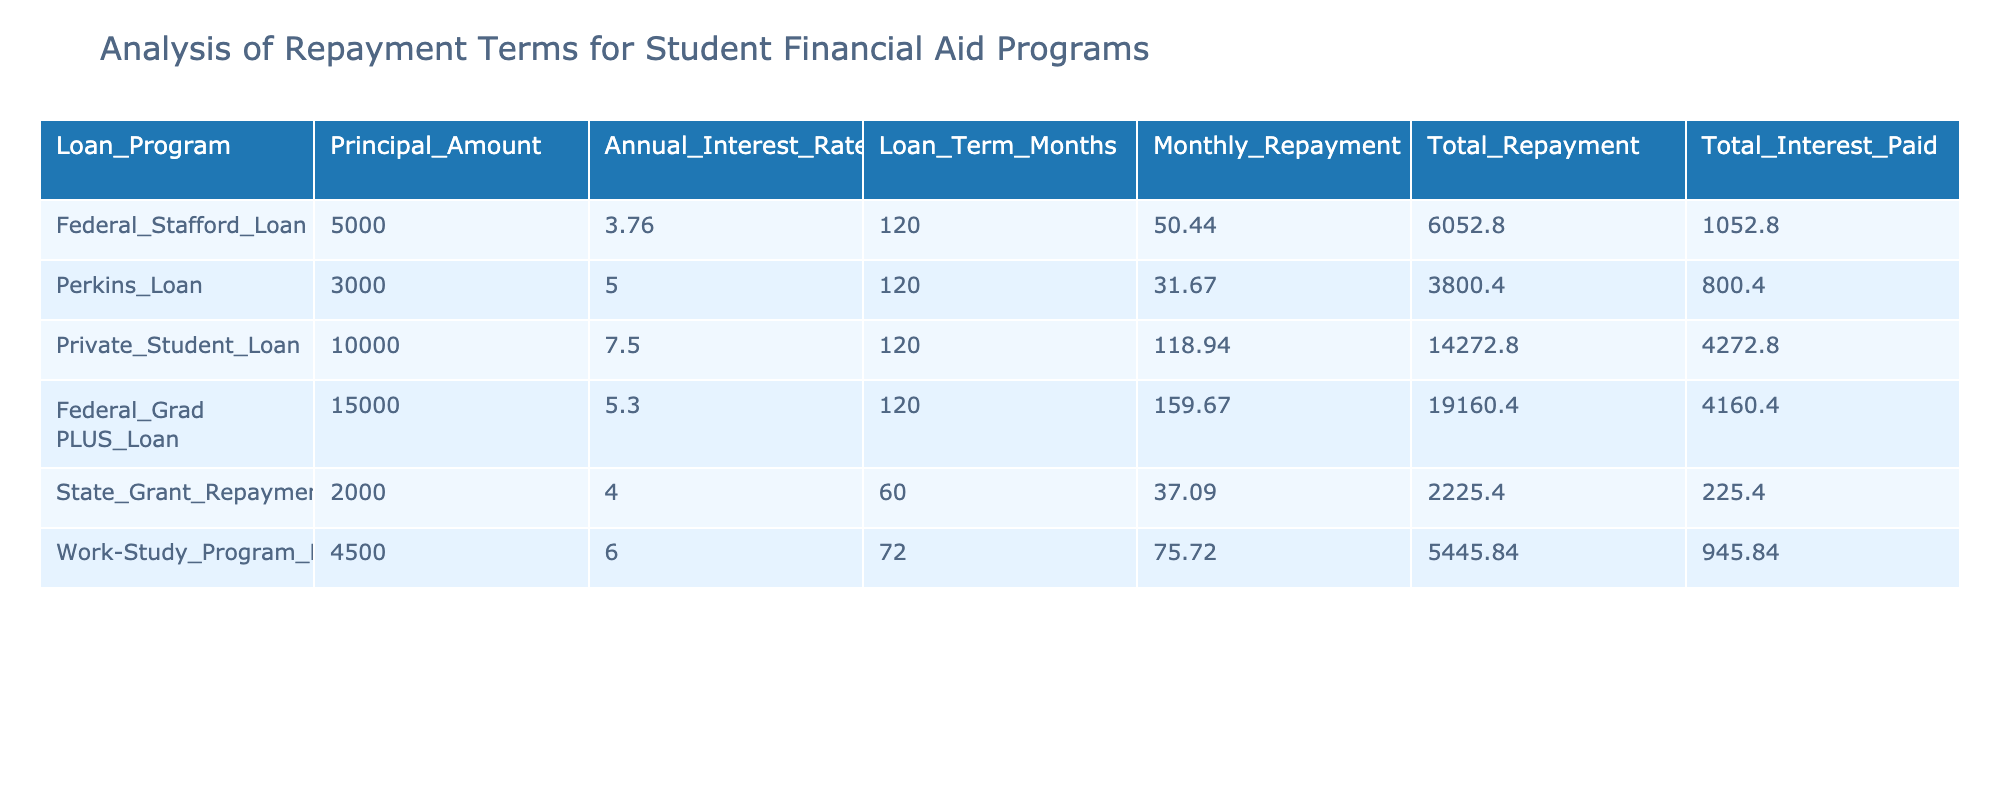What is the monthly repayment amount for the Perkins Loan? The table shows that the monthly repayment for the Perkins Loan is listed in the corresponding row. By checking the 'Monthly_Repayment' column, we find that it is 31.67.
Answer: 31.67 Which loan program has the highest total interest paid? To find this, we compare the 'Total_Interest_Paid' values across all loan programs. The highest value is for the Private Student Loan which is 4272.80.
Answer: Private Student Loan What is the total repayment amount for all loan programs combined? We add the 'Total_Repayment' values from all the loan programs: 6052.80 + 3800.40 + 14272.80 + 19160.40 + 2225.40 + 5445.84 = 42307.64.
Answer: 42307.64 Is the Federal Grad PLUS Loan paid off faster than the Work-Study Program Loan? The loan terms for Federal Grad PLUS Loan is 120 months and for Work-Study Program Loan is 72 months. Since 72 months is less than 120 months, the Work-Study Program Loan is paid off faster.
Answer: No What is the average monthly repayment for all the loans listed in the table? To find the average, we sum the monthly repayments: 50.44 + 31.67 + 118.94 + 159.67 + 37.09 + 75.72 = 473.53. Then, we divide by the number of loan programs (6): 473.53 / 6 = 78.92.
Answer: 78.92 How much total interest would be paid if a student takes on all six loan programs? We sum the total interest paid for all programs as follows: 1052.80 + 800.40 + 4272.80 + 4160.40 + 225.40 + 945.84 = 11027.64.
Answer: 11027.64 Which loan program has the lowest principal amount, and what is that amount? Looking at the 'Principal_Amount' column, we find that the State Grant Repayment has the lowest value, which is 2000.
Answer: State Grant Repayment, 2000 Is it true that all loan programs have an interest rate greater than 3 percent? By examining the 'Annual_Interest_Rate' column, all entries show rates above 3 percent, confirming that the statement is true.
Answer: Yes How does the total repayment of the Federal Stafford Loan compare to that of the Perkins Loan? The total repayment for the Federal Stafford Loan is 6052.80 and for the Perkins Loan is 3800.40. Comparing these values shows that the Federal Stafford Loan has a higher total repayment.
Answer: Federal Stafford Loan is higher 